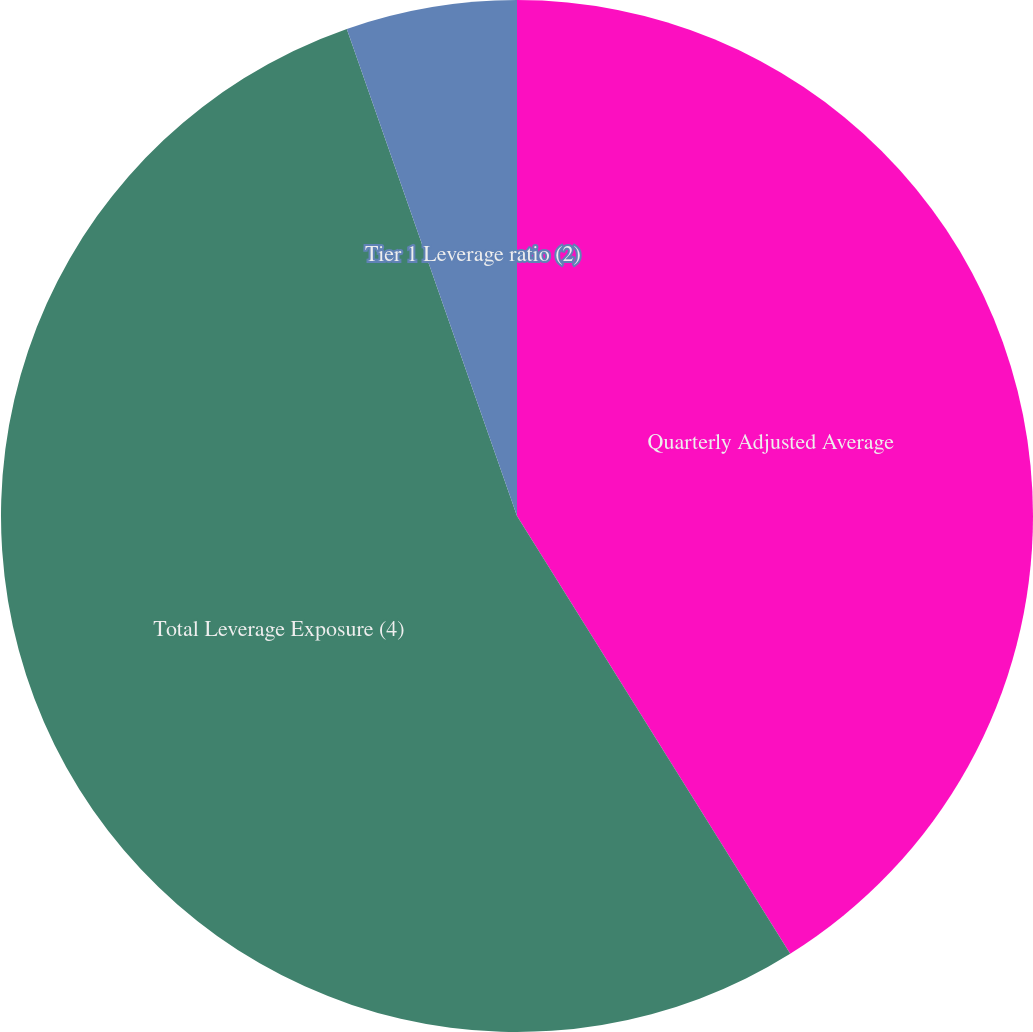Convert chart to OTSL. <chart><loc_0><loc_0><loc_500><loc_500><pie_chart><fcel>Quarterly Adjusted Average<fcel>Total Leverage Exposure (4)<fcel>Tier 1 Leverage ratio (2)<fcel>Supplementary Leverage ratio<nl><fcel>41.12%<fcel>53.53%<fcel>5.35%<fcel>0.0%<nl></chart> 